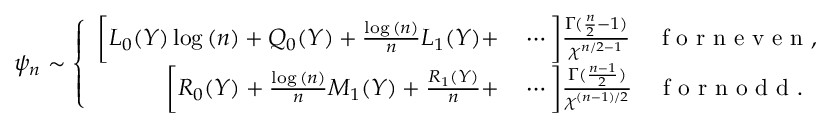Convert formula to latex. <formula><loc_0><loc_0><loc_500><loc_500>\psi _ { n } \sim \left \{ \begin{array} { r l } { \left [ L _ { 0 } ( Y ) \log { ( n ) } + Q _ { 0 } ( Y ) + \frac { \log { ( n ) } } { n } L _ { 1 } ( Y ) + } & \cdots \right ] \frac { \Gamma ( \frac { n } { 2 } - 1 ) } { \chi ^ { n / 2 - 1 } } \quad f o r n e v e n , } \\ { \left [ R _ { 0 } ( Y ) + \frac { \log { ( n ) } } { n } M _ { 1 } ( Y ) + \frac { R _ { 1 } ( Y ) } { n } + } & \cdots \right ] \frac { \Gamma ( \frac { n - 1 } { 2 } ) } { \chi ^ { ( n - 1 ) / 2 } } \quad f o r n o d d . } \end{array}</formula> 